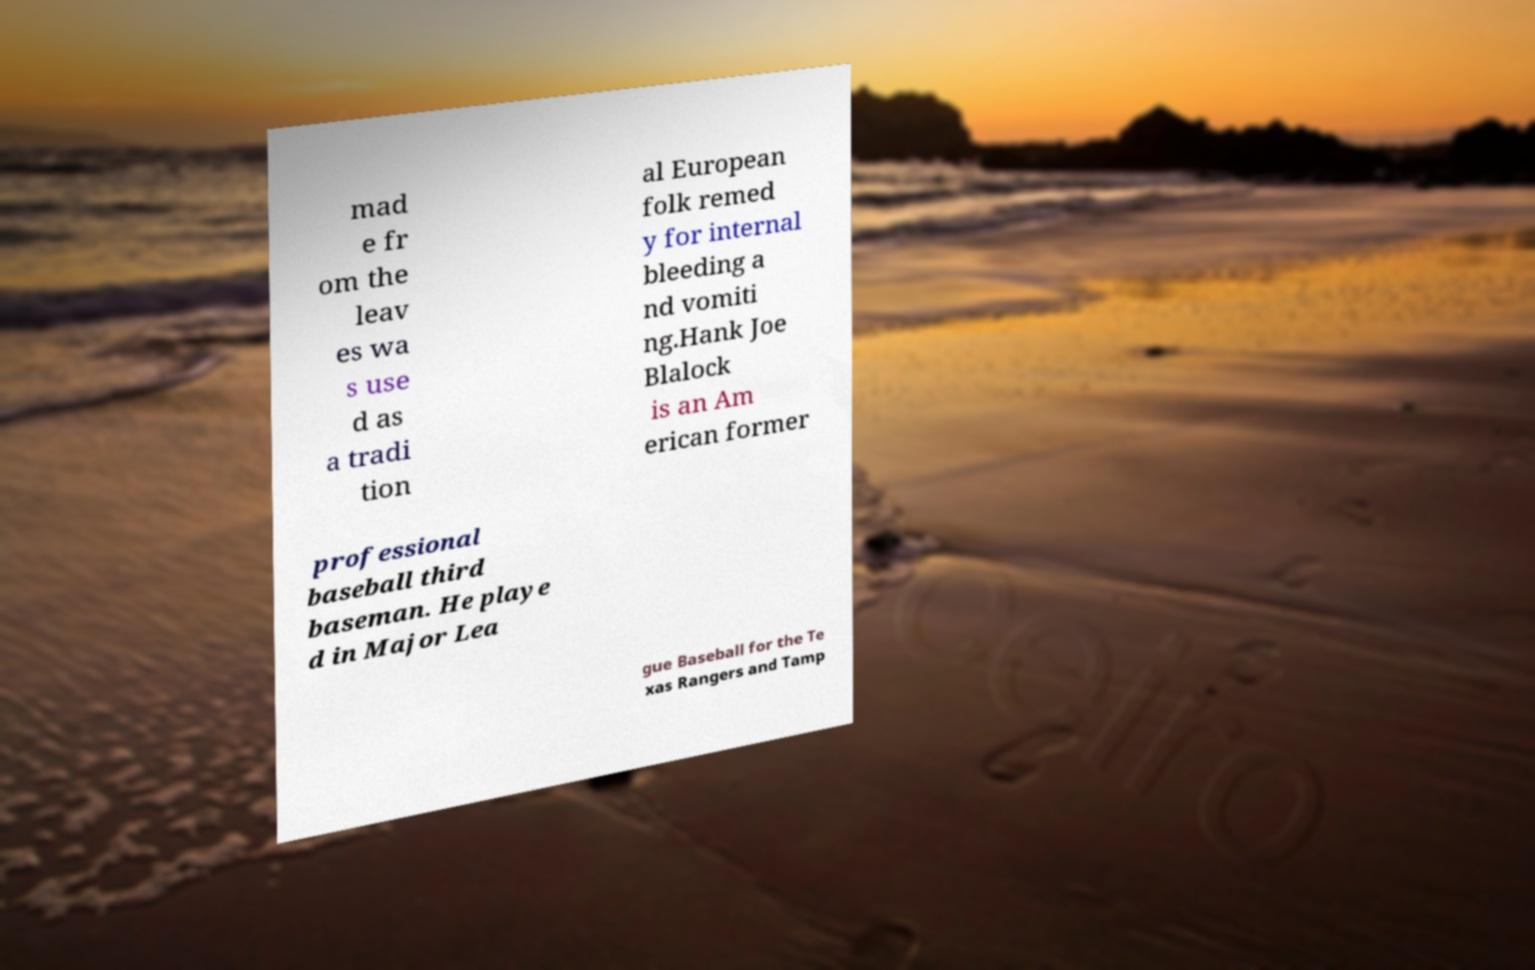Can you read and provide the text displayed in the image?This photo seems to have some interesting text. Can you extract and type it out for me? mad e fr om the leav es wa s use d as a tradi tion al European folk remed y for internal bleeding a nd vomiti ng.Hank Joe Blalock is an Am erican former professional baseball third baseman. He playe d in Major Lea gue Baseball for the Te xas Rangers and Tamp 